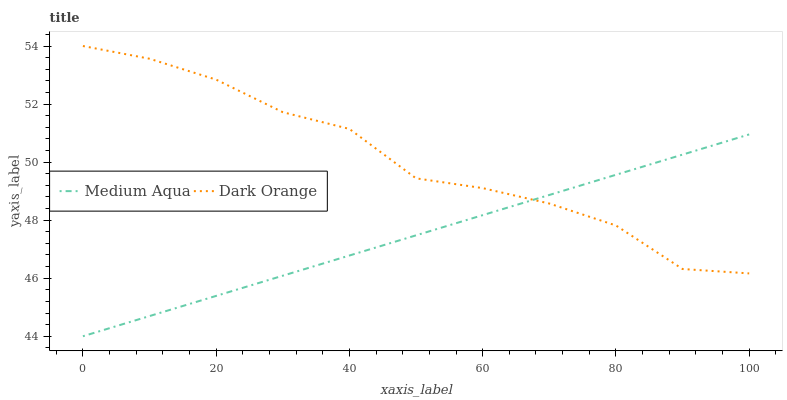Does Medium Aqua have the minimum area under the curve?
Answer yes or no. Yes. Does Dark Orange have the maximum area under the curve?
Answer yes or no. Yes. Does Medium Aqua have the maximum area under the curve?
Answer yes or no. No. Is Medium Aqua the smoothest?
Answer yes or no. Yes. Is Dark Orange the roughest?
Answer yes or no. Yes. Is Medium Aqua the roughest?
Answer yes or no. No. Does Medium Aqua have the lowest value?
Answer yes or no. Yes. Does Dark Orange have the highest value?
Answer yes or no. Yes. Does Medium Aqua have the highest value?
Answer yes or no. No. Does Medium Aqua intersect Dark Orange?
Answer yes or no. Yes. Is Medium Aqua less than Dark Orange?
Answer yes or no. No. Is Medium Aqua greater than Dark Orange?
Answer yes or no. No. 